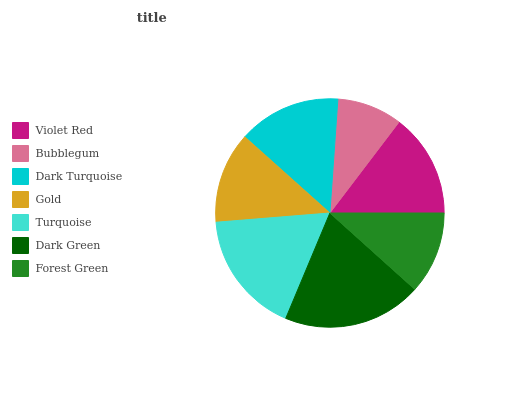Is Bubblegum the minimum?
Answer yes or no. Yes. Is Dark Green the maximum?
Answer yes or no. Yes. Is Dark Turquoise the minimum?
Answer yes or no. No. Is Dark Turquoise the maximum?
Answer yes or no. No. Is Dark Turquoise greater than Bubblegum?
Answer yes or no. Yes. Is Bubblegum less than Dark Turquoise?
Answer yes or no. Yes. Is Bubblegum greater than Dark Turquoise?
Answer yes or no. No. Is Dark Turquoise less than Bubblegum?
Answer yes or no. No. Is Dark Turquoise the high median?
Answer yes or no. Yes. Is Dark Turquoise the low median?
Answer yes or no. Yes. Is Gold the high median?
Answer yes or no. No. Is Dark Green the low median?
Answer yes or no. No. 